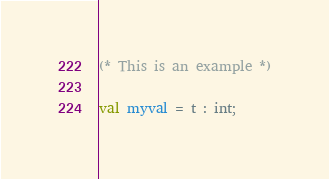<code> <loc_0><loc_0><loc_500><loc_500><_SML_>(* This is an example *)

val myval = t : int;
</code> 